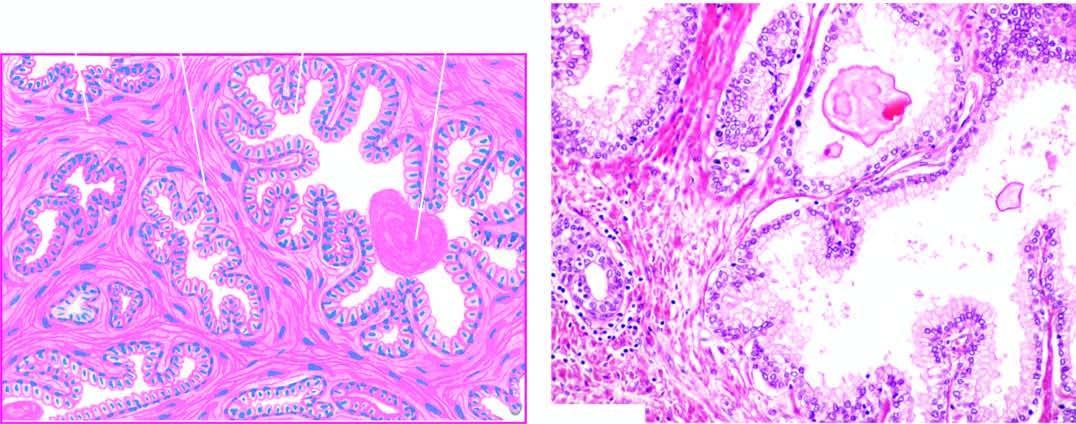what are lined by two layers of epithelium with basal polarity of nuclei?
Answer the question using a single word or phrase. Areas of intra-acinar papillary infoldings 